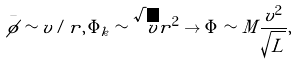<formula> <loc_0><loc_0><loc_500><loc_500>\bar { \phi } \sim v / r , \, \Phi _ { k } \sim \sqrt { v } r ^ { 2 } \to \Phi \sim M \frac { v ^ { 2 } } { \sqrt { L } } ,</formula> 